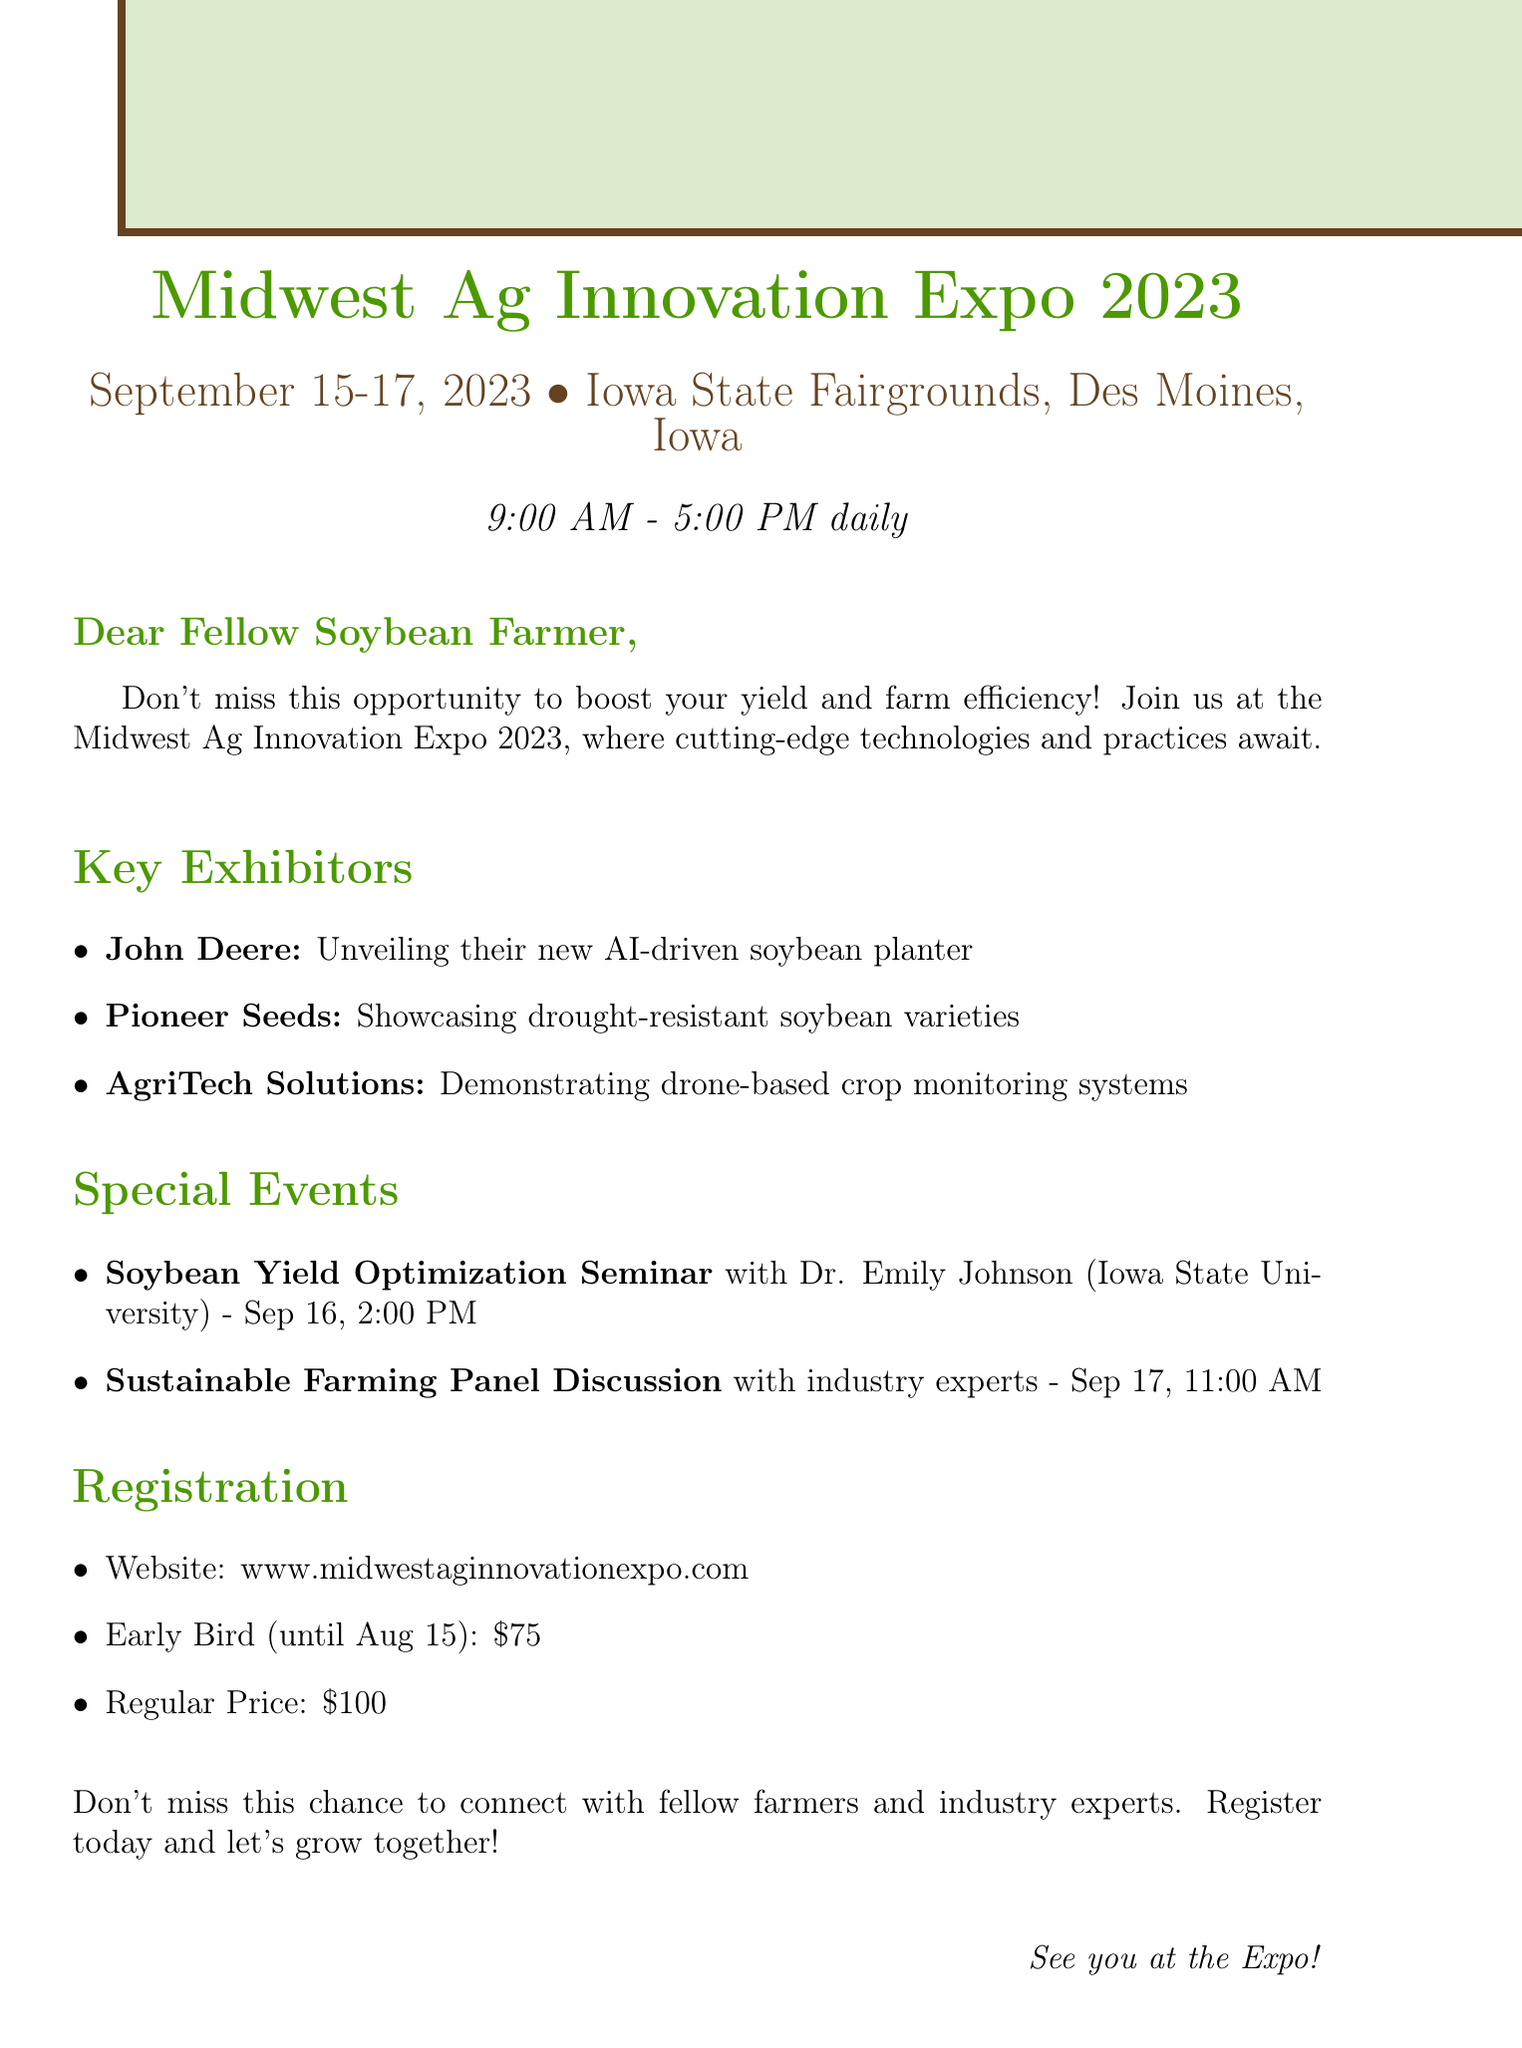What are the dates of the expo? The document specifies the event dates as September 15-17, 2023.
Answer: September 15-17, 2023 Where is the Midwest Ag Innovation Expo held? The location provided in the document is the Iowa State Fairgrounds, Des Moines, Iowa.
Answer: Iowa State Fairgrounds, Des Moines, Iowa Who is the speaker for the Soybean Yield Optimization Seminar? The document states that Dr. Emily Johnson from Iowa State University will be the speaker.
Answer: Dr. Emily Johnson What time does the expo start daily? The document mentions that the expo starts at 9:00 AM daily.
Answer: 9:00 AM What is the early bird registration price? According to the document, the early bird registration price is $75.
Answer: $75 Which exhibitor is showcasing drought-resistant soybean varieties? The document highlights Pioneer Seeds as the exhibitor for drought-resistant soybean varieties.
Answer: Pioneer Seeds What is the focus of the Sustainable Farming Panel Discussion? The document indicates that the panel will include industry experts and successful farmers discussing sustainable farming practices.
Answer: Industry experts and successful farmers What is one of the main value propositions of the expo? The document highlights the opportunity to discover technologies and practices to boost yield and efficiency as a key proposition.
Answer: Boost your soybean yield and farm efficiency When is the early bird registration deadline? The document specifies the early bird registration deadline as August 15, 2023.
Answer: August 15, 2023 